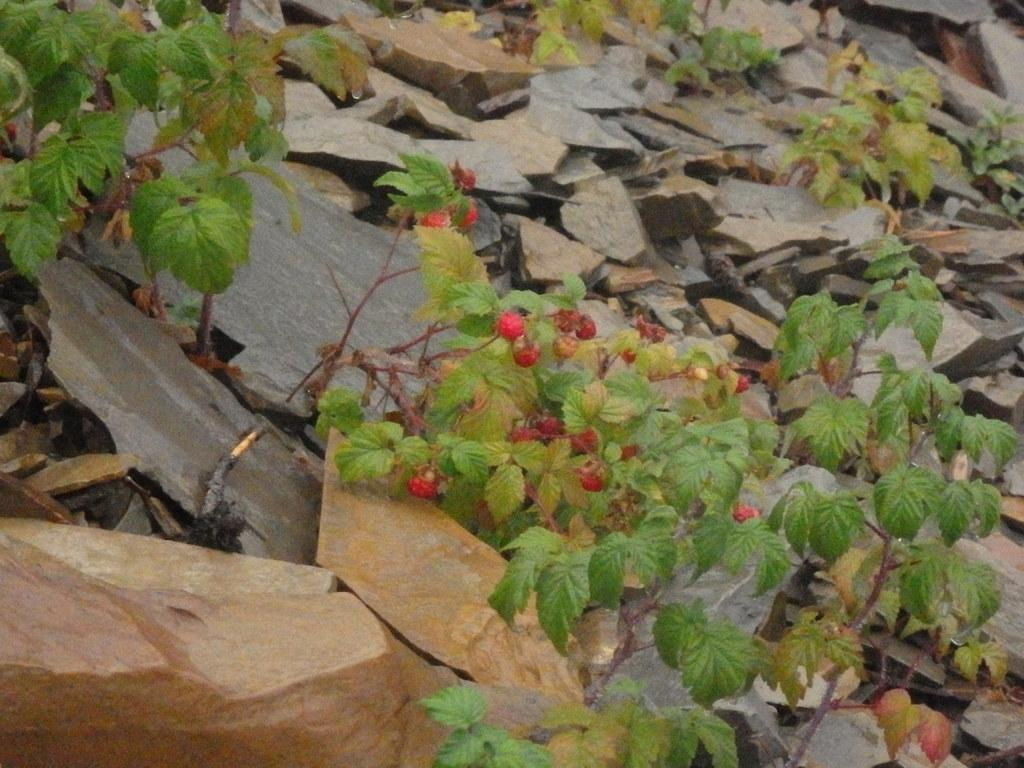What type of natural objects can be seen in the image? There are rocks in the image. What type of living organisms can be seen in the image? There are fruits on plants in the image. What religious beliefs are represented by the fruits on plants in the image? There is no indication of any religious beliefs in the image; it simply shows fruits on plants. Can you provide a list of all the cups visible in the image? There are no cups present in the image. 